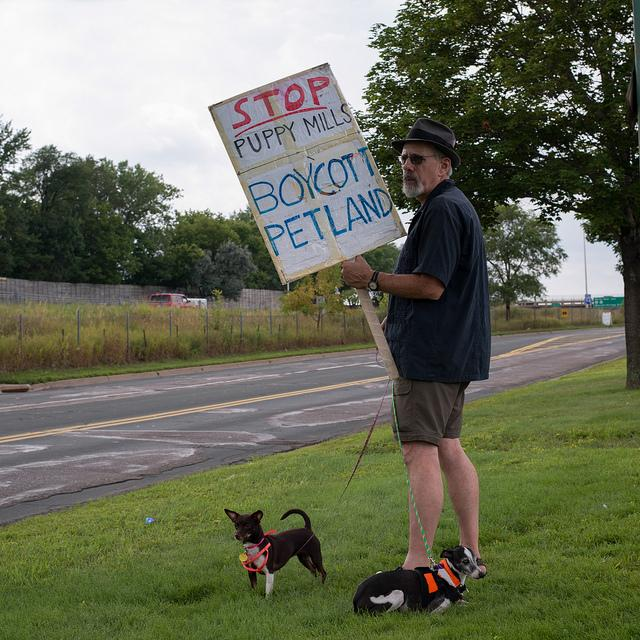What sort of life does this man advocate for? Please explain your reasoning. canines. The man wants to prevent dogs from being abused. 